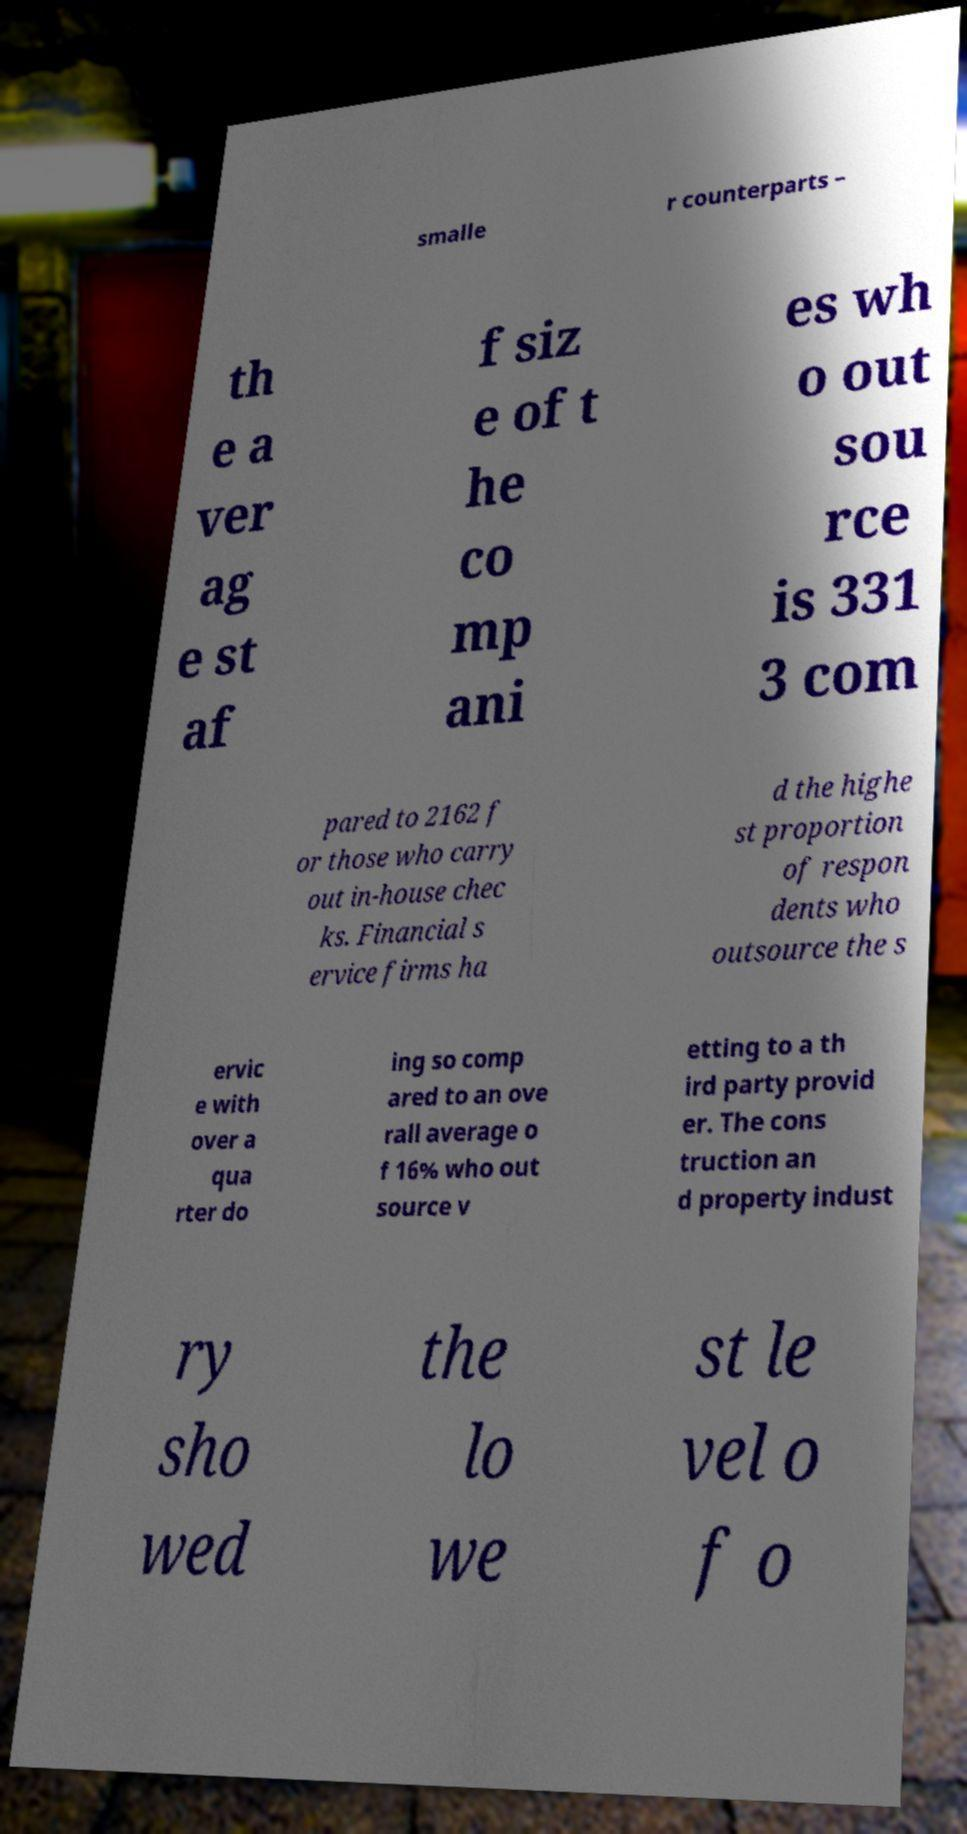Please identify and transcribe the text found in this image. smalle r counterparts – th e a ver ag e st af f siz e of t he co mp ani es wh o out sou rce is 331 3 com pared to 2162 f or those who carry out in-house chec ks. Financial s ervice firms ha d the highe st proportion of respon dents who outsource the s ervic e with over a qua rter do ing so comp ared to an ove rall average o f 16% who out source v etting to a th ird party provid er. The cons truction an d property indust ry sho wed the lo we st le vel o f o 